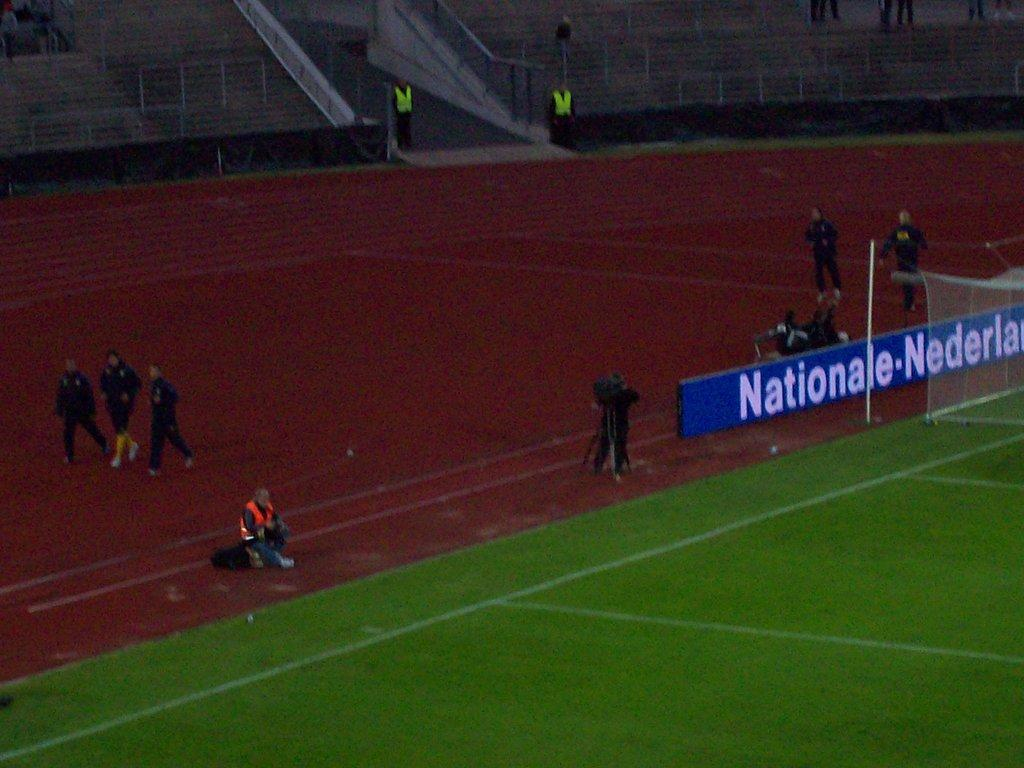What is the main subject of the image? The main subject of the image is a playground. Are there any people near the playground? Yes, there are people behind the playground. What else can be seen in the image besides the playground and people? There is a banner and an empty stadium in the background. Are there any people in the empty stadium? Yes, there are some people in the empty stadium. What type of toothpaste is being advertised on the banner in the image? There is no toothpaste being advertised on the banner in the image; it is a playground with a banner, but the content of the banner is not mentioned in the facts. 